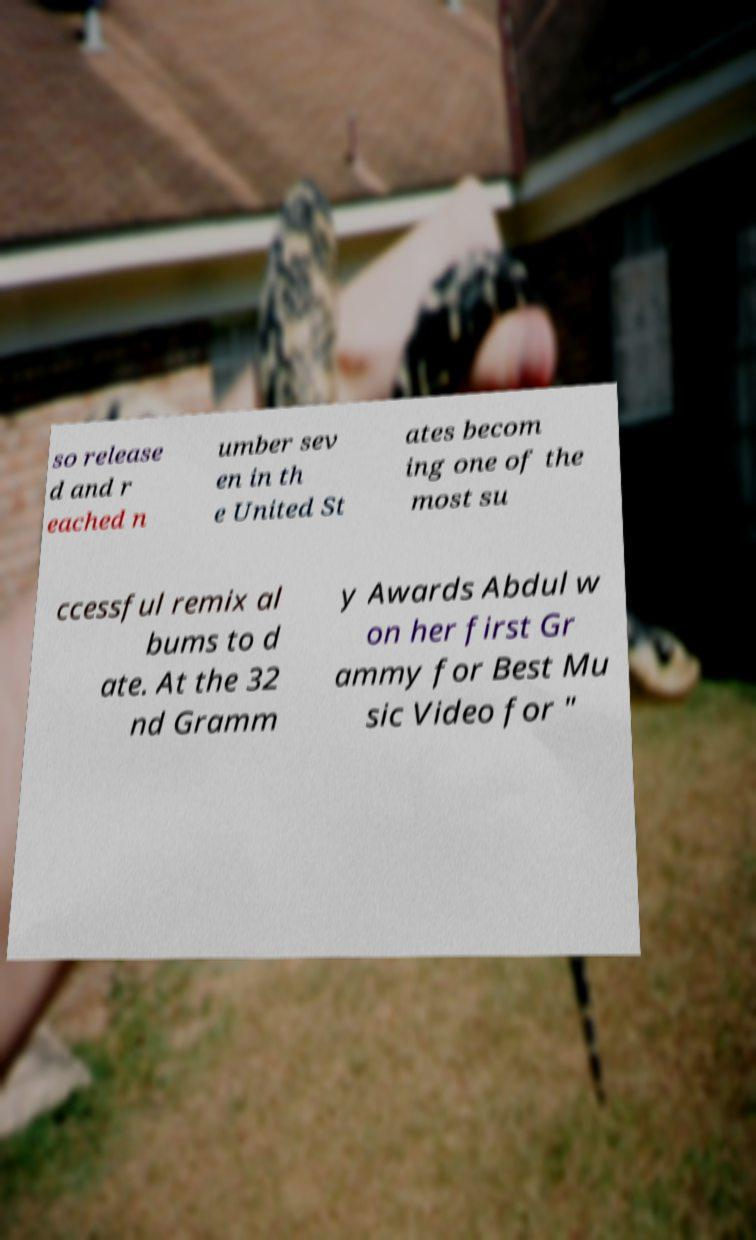I need the written content from this picture converted into text. Can you do that? so release d and r eached n umber sev en in th e United St ates becom ing one of the most su ccessful remix al bums to d ate. At the 32 nd Gramm y Awards Abdul w on her first Gr ammy for Best Mu sic Video for " 